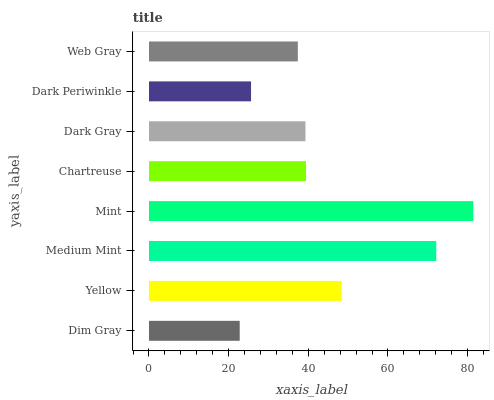Is Dim Gray the minimum?
Answer yes or no. Yes. Is Mint the maximum?
Answer yes or no. Yes. Is Yellow the minimum?
Answer yes or no. No. Is Yellow the maximum?
Answer yes or no. No. Is Yellow greater than Dim Gray?
Answer yes or no. Yes. Is Dim Gray less than Yellow?
Answer yes or no. Yes. Is Dim Gray greater than Yellow?
Answer yes or no. No. Is Yellow less than Dim Gray?
Answer yes or no. No. Is Chartreuse the high median?
Answer yes or no. Yes. Is Dark Gray the low median?
Answer yes or no. Yes. Is Dark Gray the high median?
Answer yes or no. No. Is Mint the low median?
Answer yes or no. No. 